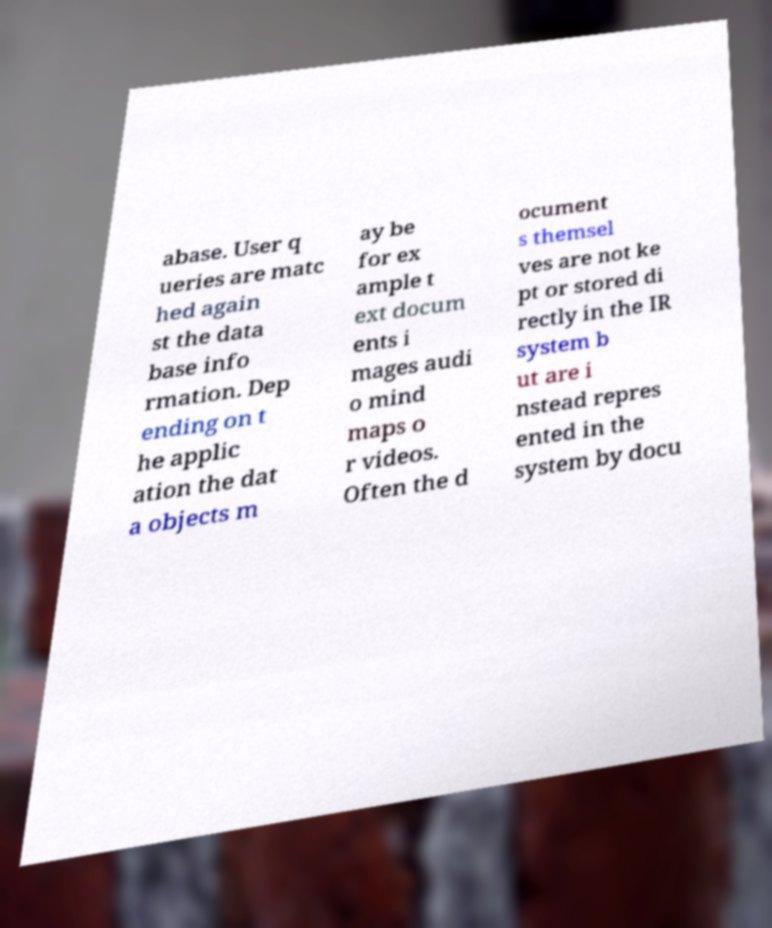Please identify and transcribe the text found in this image. abase. User q ueries are matc hed again st the data base info rmation. Dep ending on t he applic ation the dat a objects m ay be for ex ample t ext docum ents i mages audi o mind maps o r videos. Often the d ocument s themsel ves are not ke pt or stored di rectly in the IR system b ut are i nstead repres ented in the system by docu 